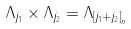<formula> <loc_0><loc_0><loc_500><loc_500>\Lambda _ { j _ { 1 } } \times \Lambda _ { j _ { 2 } } = \Lambda _ { \left [ j _ { 1 } + j _ { 2 } \right ] _ { n } }</formula> 